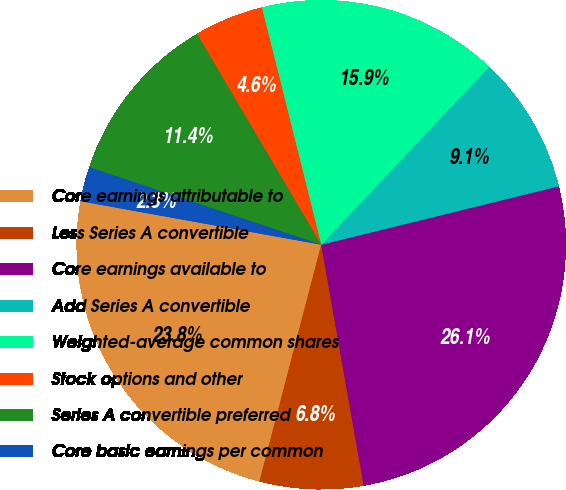<chart> <loc_0><loc_0><loc_500><loc_500><pie_chart><fcel>Core earnings attributable to<fcel>Less Series A convertible<fcel>Core earnings available to<fcel>Add Series A convertible<fcel>Weighted-average common shares<fcel>Stock options and other<fcel>Series A convertible preferred<fcel>Core basic earnings per common<nl><fcel>23.78%<fcel>6.84%<fcel>26.06%<fcel>9.12%<fcel>15.94%<fcel>4.57%<fcel>11.39%<fcel>2.29%<nl></chart> 